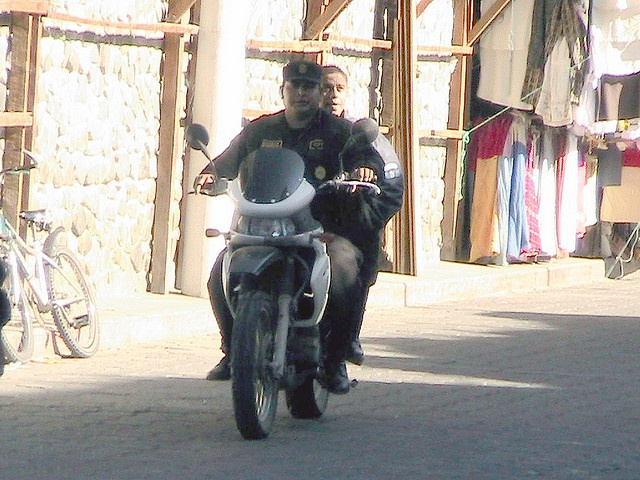Describe the objects in this image and their specific colors. I can see motorcycle in beige, black, gray, purple, and darkgray tones, bicycle in beige, ivory, darkgray, and tan tones, people in beige, black, gray, and purple tones, people in beige, black, and gray tones, and people in beige, lightgray, gray, darkgray, and black tones in this image. 